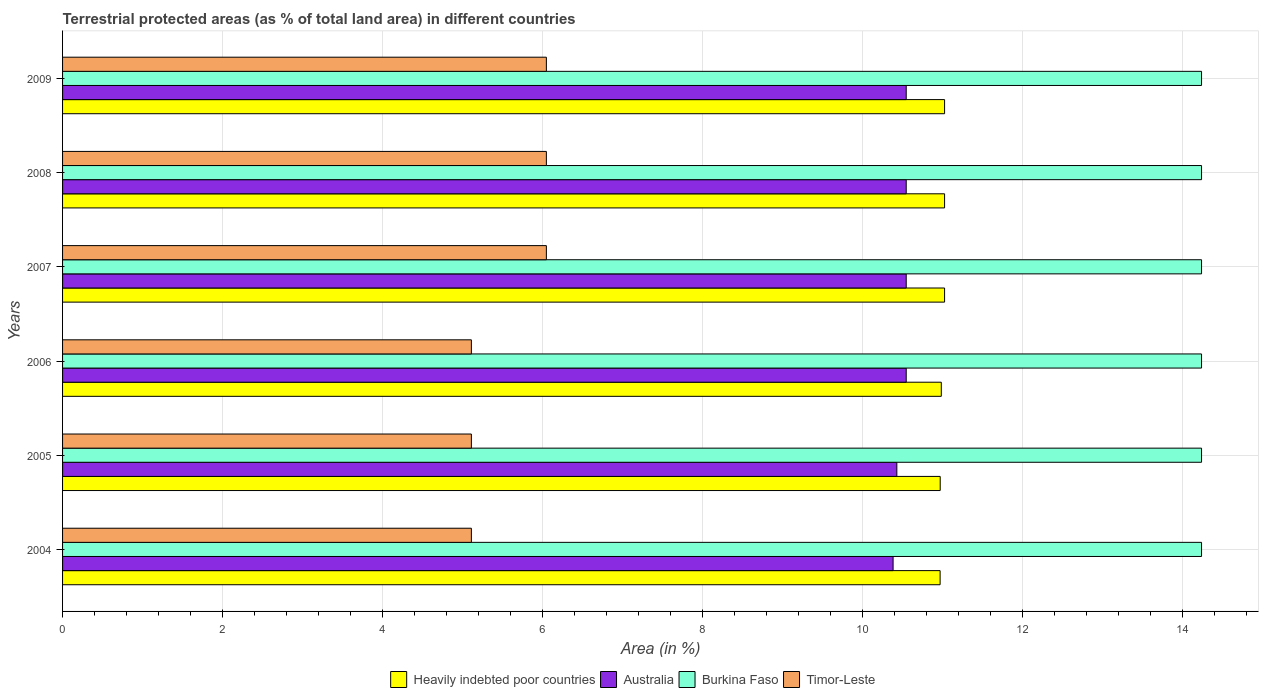How many different coloured bars are there?
Provide a succinct answer. 4. How many bars are there on the 6th tick from the bottom?
Provide a succinct answer. 4. What is the percentage of terrestrial protected land in Timor-Leste in 2006?
Offer a very short reply. 5.11. Across all years, what is the maximum percentage of terrestrial protected land in Heavily indebted poor countries?
Give a very brief answer. 11.03. Across all years, what is the minimum percentage of terrestrial protected land in Australia?
Give a very brief answer. 10.39. In which year was the percentage of terrestrial protected land in Timor-Leste minimum?
Ensure brevity in your answer.  2004. What is the total percentage of terrestrial protected land in Australia in the graph?
Provide a short and direct response. 63.02. What is the difference between the percentage of terrestrial protected land in Australia in 2004 and that in 2007?
Make the answer very short. -0.16. What is the difference between the percentage of terrestrial protected land in Heavily indebted poor countries in 2004 and the percentage of terrestrial protected land in Burkina Faso in 2009?
Your answer should be compact. -3.27. What is the average percentage of terrestrial protected land in Burkina Faso per year?
Provide a succinct answer. 14.24. In the year 2009, what is the difference between the percentage of terrestrial protected land in Heavily indebted poor countries and percentage of terrestrial protected land in Australia?
Offer a terse response. 0.48. In how many years, is the percentage of terrestrial protected land in Timor-Leste greater than 8.8 %?
Your answer should be very brief. 0. What is the ratio of the percentage of terrestrial protected land in Timor-Leste in 2005 to that in 2007?
Offer a very short reply. 0.84. Is the percentage of terrestrial protected land in Heavily indebted poor countries in 2007 less than that in 2009?
Provide a short and direct response. No. Is the difference between the percentage of terrestrial protected land in Heavily indebted poor countries in 2005 and 2008 greater than the difference between the percentage of terrestrial protected land in Australia in 2005 and 2008?
Keep it short and to the point. Yes. What is the difference between the highest and the lowest percentage of terrestrial protected land in Australia?
Your response must be concise. 0.16. Is it the case that in every year, the sum of the percentage of terrestrial protected land in Timor-Leste and percentage of terrestrial protected land in Australia is greater than the sum of percentage of terrestrial protected land in Heavily indebted poor countries and percentage of terrestrial protected land in Burkina Faso?
Offer a very short reply. No. What does the 4th bar from the bottom in 2007 represents?
Keep it short and to the point. Timor-Leste. Is it the case that in every year, the sum of the percentage of terrestrial protected land in Timor-Leste and percentage of terrestrial protected land in Burkina Faso is greater than the percentage of terrestrial protected land in Australia?
Your answer should be compact. Yes. Are all the bars in the graph horizontal?
Provide a succinct answer. Yes. What is the difference between two consecutive major ticks on the X-axis?
Provide a succinct answer. 2. Does the graph contain grids?
Provide a succinct answer. Yes. Where does the legend appear in the graph?
Keep it short and to the point. Bottom center. How many legend labels are there?
Your answer should be very brief. 4. What is the title of the graph?
Give a very brief answer. Terrestrial protected areas (as % of total land area) in different countries. Does "Georgia" appear as one of the legend labels in the graph?
Offer a terse response. No. What is the label or title of the X-axis?
Your answer should be very brief. Area (in %). What is the Area (in %) in Heavily indebted poor countries in 2004?
Your answer should be compact. 10.97. What is the Area (in %) of Australia in 2004?
Provide a short and direct response. 10.39. What is the Area (in %) of Burkina Faso in 2004?
Offer a terse response. 14.24. What is the Area (in %) of Timor-Leste in 2004?
Offer a terse response. 5.11. What is the Area (in %) in Heavily indebted poor countries in 2005?
Provide a succinct answer. 10.98. What is the Area (in %) in Australia in 2005?
Your answer should be very brief. 10.43. What is the Area (in %) in Burkina Faso in 2005?
Your answer should be compact. 14.24. What is the Area (in %) of Timor-Leste in 2005?
Offer a very short reply. 5.11. What is the Area (in %) in Heavily indebted poor countries in 2006?
Offer a very short reply. 10.99. What is the Area (in %) of Australia in 2006?
Ensure brevity in your answer.  10.55. What is the Area (in %) of Burkina Faso in 2006?
Your response must be concise. 14.24. What is the Area (in %) in Timor-Leste in 2006?
Offer a very short reply. 5.11. What is the Area (in %) of Heavily indebted poor countries in 2007?
Keep it short and to the point. 11.03. What is the Area (in %) in Australia in 2007?
Offer a very short reply. 10.55. What is the Area (in %) of Burkina Faso in 2007?
Offer a very short reply. 14.24. What is the Area (in %) of Timor-Leste in 2007?
Your answer should be compact. 6.05. What is the Area (in %) of Heavily indebted poor countries in 2008?
Offer a terse response. 11.03. What is the Area (in %) in Australia in 2008?
Keep it short and to the point. 10.55. What is the Area (in %) in Burkina Faso in 2008?
Provide a short and direct response. 14.24. What is the Area (in %) in Timor-Leste in 2008?
Give a very brief answer. 6.05. What is the Area (in %) in Heavily indebted poor countries in 2009?
Your answer should be compact. 11.03. What is the Area (in %) in Australia in 2009?
Ensure brevity in your answer.  10.55. What is the Area (in %) of Burkina Faso in 2009?
Offer a terse response. 14.24. What is the Area (in %) of Timor-Leste in 2009?
Ensure brevity in your answer.  6.05. Across all years, what is the maximum Area (in %) in Heavily indebted poor countries?
Provide a succinct answer. 11.03. Across all years, what is the maximum Area (in %) in Australia?
Make the answer very short. 10.55. Across all years, what is the maximum Area (in %) of Burkina Faso?
Ensure brevity in your answer.  14.24. Across all years, what is the maximum Area (in %) of Timor-Leste?
Give a very brief answer. 6.05. Across all years, what is the minimum Area (in %) of Heavily indebted poor countries?
Provide a succinct answer. 10.97. Across all years, what is the minimum Area (in %) in Australia?
Your answer should be very brief. 10.39. Across all years, what is the minimum Area (in %) of Burkina Faso?
Your answer should be compact. 14.24. Across all years, what is the minimum Area (in %) of Timor-Leste?
Give a very brief answer. 5.11. What is the total Area (in %) of Heavily indebted poor countries in the graph?
Make the answer very short. 66.03. What is the total Area (in %) of Australia in the graph?
Your answer should be compact. 63.02. What is the total Area (in %) in Burkina Faso in the graph?
Provide a succinct answer. 85.46. What is the total Area (in %) of Timor-Leste in the graph?
Provide a short and direct response. 33.49. What is the difference between the Area (in %) in Heavily indebted poor countries in 2004 and that in 2005?
Offer a very short reply. -0. What is the difference between the Area (in %) in Australia in 2004 and that in 2005?
Make the answer very short. -0.05. What is the difference between the Area (in %) of Timor-Leste in 2004 and that in 2005?
Give a very brief answer. 0. What is the difference between the Area (in %) in Heavily indebted poor countries in 2004 and that in 2006?
Make the answer very short. -0.01. What is the difference between the Area (in %) in Australia in 2004 and that in 2006?
Ensure brevity in your answer.  -0.16. What is the difference between the Area (in %) in Burkina Faso in 2004 and that in 2006?
Your answer should be very brief. 0. What is the difference between the Area (in %) in Timor-Leste in 2004 and that in 2006?
Offer a very short reply. 0. What is the difference between the Area (in %) of Heavily indebted poor countries in 2004 and that in 2007?
Your answer should be compact. -0.06. What is the difference between the Area (in %) of Australia in 2004 and that in 2007?
Provide a succinct answer. -0.16. What is the difference between the Area (in %) of Timor-Leste in 2004 and that in 2007?
Keep it short and to the point. -0.94. What is the difference between the Area (in %) in Heavily indebted poor countries in 2004 and that in 2008?
Make the answer very short. -0.06. What is the difference between the Area (in %) in Australia in 2004 and that in 2008?
Your response must be concise. -0.16. What is the difference between the Area (in %) of Burkina Faso in 2004 and that in 2008?
Offer a terse response. 0. What is the difference between the Area (in %) of Timor-Leste in 2004 and that in 2008?
Offer a terse response. -0.94. What is the difference between the Area (in %) of Heavily indebted poor countries in 2004 and that in 2009?
Provide a succinct answer. -0.06. What is the difference between the Area (in %) in Australia in 2004 and that in 2009?
Give a very brief answer. -0.16. What is the difference between the Area (in %) in Timor-Leste in 2004 and that in 2009?
Keep it short and to the point. -0.94. What is the difference between the Area (in %) in Heavily indebted poor countries in 2005 and that in 2006?
Your answer should be very brief. -0.01. What is the difference between the Area (in %) in Australia in 2005 and that in 2006?
Keep it short and to the point. -0.12. What is the difference between the Area (in %) in Heavily indebted poor countries in 2005 and that in 2007?
Your response must be concise. -0.05. What is the difference between the Area (in %) of Australia in 2005 and that in 2007?
Ensure brevity in your answer.  -0.12. What is the difference between the Area (in %) of Timor-Leste in 2005 and that in 2007?
Offer a terse response. -0.94. What is the difference between the Area (in %) of Heavily indebted poor countries in 2005 and that in 2008?
Offer a terse response. -0.05. What is the difference between the Area (in %) of Australia in 2005 and that in 2008?
Ensure brevity in your answer.  -0.12. What is the difference between the Area (in %) of Timor-Leste in 2005 and that in 2008?
Give a very brief answer. -0.94. What is the difference between the Area (in %) in Heavily indebted poor countries in 2005 and that in 2009?
Your response must be concise. -0.05. What is the difference between the Area (in %) of Australia in 2005 and that in 2009?
Offer a very short reply. -0.12. What is the difference between the Area (in %) of Burkina Faso in 2005 and that in 2009?
Offer a terse response. 0. What is the difference between the Area (in %) in Timor-Leste in 2005 and that in 2009?
Provide a succinct answer. -0.94. What is the difference between the Area (in %) in Heavily indebted poor countries in 2006 and that in 2007?
Provide a succinct answer. -0.04. What is the difference between the Area (in %) in Timor-Leste in 2006 and that in 2007?
Keep it short and to the point. -0.94. What is the difference between the Area (in %) in Heavily indebted poor countries in 2006 and that in 2008?
Offer a very short reply. -0.04. What is the difference between the Area (in %) in Australia in 2006 and that in 2008?
Your response must be concise. -0. What is the difference between the Area (in %) in Timor-Leste in 2006 and that in 2008?
Make the answer very short. -0.94. What is the difference between the Area (in %) of Heavily indebted poor countries in 2006 and that in 2009?
Provide a short and direct response. -0.04. What is the difference between the Area (in %) in Australia in 2006 and that in 2009?
Offer a very short reply. -0. What is the difference between the Area (in %) in Timor-Leste in 2006 and that in 2009?
Offer a terse response. -0.94. What is the difference between the Area (in %) of Heavily indebted poor countries in 2007 and that in 2008?
Provide a succinct answer. 0. What is the difference between the Area (in %) of Australia in 2007 and that in 2008?
Your response must be concise. 0. What is the difference between the Area (in %) of Burkina Faso in 2007 and that in 2008?
Make the answer very short. 0. What is the difference between the Area (in %) in Timor-Leste in 2007 and that in 2009?
Give a very brief answer. 0. What is the difference between the Area (in %) in Heavily indebted poor countries in 2008 and that in 2009?
Give a very brief answer. 0. What is the difference between the Area (in %) of Australia in 2008 and that in 2009?
Your answer should be compact. 0. What is the difference between the Area (in %) of Burkina Faso in 2008 and that in 2009?
Your response must be concise. 0. What is the difference between the Area (in %) in Timor-Leste in 2008 and that in 2009?
Provide a short and direct response. 0. What is the difference between the Area (in %) in Heavily indebted poor countries in 2004 and the Area (in %) in Australia in 2005?
Offer a terse response. 0.54. What is the difference between the Area (in %) in Heavily indebted poor countries in 2004 and the Area (in %) in Burkina Faso in 2005?
Keep it short and to the point. -3.27. What is the difference between the Area (in %) in Heavily indebted poor countries in 2004 and the Area (in %) in Timor-Leste in 2005?
Make the answer very short. 5.86. What is the difference between the Area (in %) of Australia in 2004 and the Area (in %) of Burkina Faso in 2005?
Your response must be concise. -3.86. What is the difference between the Area (in %) in Australia in 2004 and the Area (in %) in Timor-Leste in 2005?
Provide a succinct answer. 5.27. What is the difference between the Area (in %) of Burkina Faso in 2004 and the Area (in %) of Timor-Leste in 2005?
Offer a very short reply. 9.13. What is the difference between the Area (in %) of Heavily indebted poor countries in 2004 and the Area (in %) of Australia in 2006?
Offer a very short reply. 0.42. What is the difference between the Area (in %) in Heavily indebted poor countries in 2004 and the Area (in %) in Burkina Faso in 2006?
Your response must be concise. -3.27. What is the difference between the Area (in %) in Heavily indebted poor countries in 2004 and the Area (in %) in Timor-Leste in 2006?
Offer a terse response. 5.86. What is the difference between the Area (in %) in Australia in 2004 and the Area (in %) in Burkina Faso in 2006?
Offer a very short reply. -3.86. What is the difference between the Area (in %) in Australia in 2004 and the Area (in %) in Timor-Leste in 2006?
Your response must be concise. 5.27. What is the difference between the Area (in %) in Burkina Faso in 2004 and the Area (in %) in Timor-Leste in 2006?
Make the answer very short. 9.13. What is the difference between the Area (in %) in Heavily indebted poor countries in 2004 and the Area (in %) in Australia in 2007?
Provide a short and direct response. 0.42. What is the difference between the Area (in %) of Heavily indebted poor countries in 2004 and the Area (in %) of Burkina Faso in 2007?
Give a very brief answer. -3.27. What is the difference between the Area (in %) of Heavily indebted poor countries in 2004 and the Area (in %) of Timor-Leste in 2007?
Offer a very short reply. 4.92. What is the difference between the Area (in %) of Australia in 2004 and the Area (in %) of Burkina Faso in 2007?
Make the answer very short. -3.86. What is the difference between the Area (in %) in Australia in 2004 and the Area (in %) in Timor-Leste in 2007?
Give a very brief answer. 4.34. What is the difference between the Area (in %) in Burkina Faso in 2004 and the Area (in %) in Timor-Leste in 2007?
Your answer should be compact. 8.19. What is the difference between the Area (in %) in Heavily indebted poor countries in 2004 and the Area (in %) in Australia in 2008?
Provide a short and direct response. 0.42. What is the difference between the Area (in %) of Heavily indebted poor countries in 2004 and the Area (in %) of Burkina Faso in 2008?
Give a very brief answer. -3.27. What is the difference between the Area (in %) of Heavily indebted poor countries in 2004 and the Area (in %) of Timor-Leste in 2008?
Your answer should be very brief. 4.92. What is the difference between the Area (in %) in Australia in 2004 and the Area (in %) in Burkina Faso in 2008?
Offer a terse response. -3.86. What is the difference between the Area (in %) in Australia in 2004 and the Area (in %) in Timor-Leste in 2008?
Give a very brief answer. 4.34. What is the difference between the Area (in %) of Burkina Faso in 2004 and the Area (in %) of Timor-Leste in 2008?
Provide a short and direct response. 8.19. What is the difference between the Area (in %) of Heavily indebted poor countries in 2004 and the Area (in %) of Australia in 2009?
Provide a short and direct response. 0.42. What is the difference between the Area (in %) of Heavily indebted poor countries in 2004 and the Area (in %) of Burkina Faso in 2009?
Offer a very short reply. -3.27. What is the difference between the Area (in %) of Heavily indebted poor countries in 2004 and the Area (in %) of Timor-Leste in 2009?
Offer a very short reply. 4.92. What is the difference between the Area (in %) in Australia in 2004 and the Area (in %) in Burkina Faso in 2009?
Offer a terse response. -3.86. What is the difference between the Area (in %) of Australia in 2004 and the Area (in %) of Timor-Leste in 2009?
Offer a very short reply. 4.34. What is the difference between the Area (in %) of Burkina Faso in 2004 and the Area (in %) of Timor-Leste in 2009?
Give a very brief answer. 8.19. What is the difference between the Area (in %) in Heavily indebted poor countries in 2005 and the Area (in %) in Australia in 2006?
Give a very brief answer. 0.43. What is the difference between the Area (in %) of Heavily indebted poor countries in 2005 and the Area (in %) of Burkina Faso in 2006?
Provide a short and direct response. -3.27. What is the difference between the Area (in %) of Heavily indebted poor countries in 2005 and the Area (in %) of Timor-Leste in 2006?
Your response must be concise. 5.86. What is the difference between the Area (in %) in Australia in 2005 and the Area (in %) in Burkina Faso in 2006?
Offer a terse response. -3.81. What is the difference between the Area (in %) in Australia in 2005 and the Area (in %) in Timor-Leste in 2006?
Your response must be concise. 5.32. What is the difference between the Area (in %) in Burkina Faso in 2005 and the Area (in %) in Timor-Leste in 2006?
Your response must be concise. 9.13. What is the difference between the Area (in %) in Heavily indebted poor countries in 2005 and the Area (in %) in Australia in 2007?
Offer a very short reply. 0.43. What is the difference between the Area (in %) in Heavily indebted poor countries in 2005 and the Area (in %) in Burkina Faso in 2007?
Your answer should be very brief. -3.27. What is the difference between the Area (in %) in Heavily indebted poor countries in 2005 and the Area (in %) in Timor-Leste in 2007?
Offer a very short reply. 4.92. What is the difference between the Area (in %) in Australia in 2005 and the Area (in %) in Burkina Faso in 2007?
Give a very brief answer. -3.81. What is the difference between the Area (in %) of Australia in 2005 and the Area (in %) of Timor-Leste in 2007?
Your answer should be very brief. 4.38. What is the difference between the Area (in %) of Burkina Faso in 2005 and the Area (in %) of Timor-Leste in 2007?
Give a very brief answer. 8.19. What is the difference between the Area (in %) in Heavily indebted poor countries in 2005 and the Area (in %) in Australia in 2008?
Offer a terse response. 0.43. What is the difference between the Area (in %) of Heavily indebted poor countries in 2005 and the Area (in %) of Burkina Faso in 2008?
Provide a succinct answer. -3.27. What is the difference between the Area (in %) of Heavily indebted poor countries in 2005 and the Area (in %) of Timor-Leste in 2008?
Make the answer very short. 4.92. What is the difference between the Area (in %) in Australia in 2005 and the Area (in %) in Burkina Faso in 2008?
Offer a very short reply. -3.81. What is the difference between the Area (in %) in Australia in 2005 and the Area (in %) in Timor-Leste in 2008?
Make the answer very short. 4.38. What is the difference between the Area (in %) of Burkina Faso in 2005 and the Area (in %) of Timor-Leste in 2008?
Make the answer very short. 8.19. What is the difference between the Area (in %) of Heavily indebted poor countries in 2005 and the Area (in %) of Australia in 2009?
Ensure brevity in your answer.  0.43. What is the difference between the Area (in %) in Heavily indebted poor countries in 2005 and the Area (in %) in Burkina Faso in 2009?
Offer a terse response. -3.27. What is the difference between the Area (in %) of Heavily indebted poor countries in 2005 and the Area (in %) of Timor-Leste in 2009?
Offer a very short reply. 4.92. What is the difference between the Area (in %) of Australia in 2005 and the Area (in %) of Burkina Faso in 2009?
Provide a short and direct response. -3.81. What is the difference between the Area (in %) in Australia in 2005 and the Area (in %) in Timor-Leste in 2009?
Provide a short and direct response. 4.38. What is the difference between the Area (in %) in Burkina Faso in 2005 and the Area (in %) in Timor-Leste in 2009?
Your answer should be compact. 8.19. What is the difference between the Area (in %) in Heavily indebted poor countries in 2006 and the Area (in %) in Australia in 2007?
Ensure brevity in your answer.  0.44. What is the difference between the Area (in %) of Heavily indebted poor countries in 2006 and the Area (in %) of Burkina Faso in 2007?
Make the answer very short. -3.25. What is the difference between the Area (in %) of Heavily indebted poor countries in 2006 and the Area (in %) of Timor-Leste in 2007?
Provide a short and direct response. 4.94. What is the difference between the Area (in %) in Australia in 2006 and the Area (in %) in Burkina Faso in 2007?
Provide a short and direct response. -3.69. What is the difference between the Area (in %) in Australia in 2006 and the Area (in %) in Timor-Leste in 2007?
Provide a short and direct response. 4.5. What is the difference between the Area (in %) of Burkina Faso in 2006 and the Area (in %) of Timor-Leste in 2007?
Ensure brevity in your answer.  8.19. What is the difference between the Area (in %) of Heavily indebted poor countries in 2006 and the Area (in %) of Australia in 2008?
Offer a terse response. 0.44. What is the difference between the Area (in %) in Heavily indebted poor countries in 2006 and the Area (in %) in Burkina Faso in 2008?
Keep it short and to the point. -3.25. What is the difference between the Area (in %) of Heavily indebted poor countries in 2006 and the Area (in %) of Timor-Leste in 2008?
Provide a succinct answer. 4.94. What is the difference between the Area (in %) of Australia in 2006 and the Area (in %) of Burkina Faso in 2008?
Your answer should be very brief. -3.69. What is the difference between the Area (in %) of Australia in 2006 and the Area (in %) of Timor-Leste in 2008?
Provide a short and direct response. 4.5. What is the difference between the Area (in %) of Burkina Faso in 2006 and the Area (in %) of Timor-Leste in 2008?
Ensure brevity in your answer.  8.19. What is the difference between the Area (in %) of Heavily indebted poor countries in 2006 and the Area (in %) of Australia in 2009?
Your answer should be very brief. 0.44. What is the difference between the Area (in %) of Heavily indebted poor countries in 2006 and the Area (in %) of Burkina Faso in 2009?
Offer a very short reply. -3.25. What is the difference between the Area (in %) in Heavily indebted poor countries in 2006 and the Area (in %) in Timor-Leste in 2009?
Your answer should be compact. 4.94. What is the difference between the Area (in %) in Australia in 2006 and the Area (in %) in Burkina Faso in 2009?
Provide a succinct answer. -3.69. What is the difference between the Area (in %) in Australia in 2006 and the Area (in %) in Timor-Leste in 2009?
Provide a short and direct response. 4.5. What is the difference between the Area (in %) of Burkina Faso in 2006 and the Area (in %) of Timor-Leste in 2009?
Ensure brevity in your answer.  8.19. What is the difference between the Area (in %) in Heavily indebted poor countries in 2007 and the Area (in %) in Australia in 2008?
Provide a succinct answer. 0.48. What is the difference between the Area (in %) of Heavily indebted poor countries in 2007 and the Area (in %) of Burkina Faso in 2008?
Make the answer very short. -3.21. What is the difference between the Area (in %) of Heavily indebted poor countries in 2007 and the Area (in %) of Timor-Leste in 2008?
Offer a terse response. 4.98. What is the difference between the Area (in %) of Australia in 2007 and the Area (in %) of Burkina Faso in 2008?
Your answer should be compact. -3.69. What is the difference between the Area (in %) of Australia in 2007 and the Area (in %) of Timor-Leste in 2008?
Offer a terse response. 4.5. What is the difference between the Area (in %) of Burkina Faso in 2007 and the Area (in %) of Timor-Leste in 2008?
Offer a terse response. 8.19. What is the difference between the Area (in %) in Heavily indebted poor countries in 2007 and the Area (in %) in Australia in 2009?
Give a very brief answer. 0.48. What is the difference between the Area (in %) of Heavily indebted poor countries in 2007 and the Area (in %) of Burkina Faso in 2009?
Make the answer very short. -3.21. What is the difference between the Area (in %) of Heavily indebted poor countries in 2007 and the Area (in %) of Timor-Leste in 2009?
Your response must be concise. 4.98. What is the difference between the Area (in %) in Australia in 2007 and the Area (in %) in Burkina Faso in 2009?
Provide a succinct answer. -3.69. What is the difference between the Area (in %) of Australia in 2007 and the Area (in %) of Timor-Leste in 2009?
Your response must be concise. 4.5. What is the difference between the Area (in %) of Burkina Faso in 2007 and the Area (in %) of Timor-Leste in 2009?
Provide a short and direct response. 8.19. What is the difference between the Area (in %) in Heavily indebted poor countries in 2008 and the Area (in %) in Australia in 2009?
Your answer should be very brief. 0.48. What is the difference between the Area (in %) of Heavily indebted poor countries in 2008 and the Area (in %) of Burkina Faso in 2009?
Provide a short and direct response. -3.21. What is the difference between the Area (in %) of Heavily indebted poor countries in 2008 and the Area (in %) of Timor-Leste in 2009?
Your answer should be compact. 4.98. What is the difference between the Area (in %) of Australia in 2008 and the Area (in %) of Burkina Faso in 2009?
Keep it short and to the point. -3.69. What is the difference between the Area (in %) of Australia in 2008 and the Area (in %) of Timor-Leste in 2009?
Ensure brevity in your answer.  4.5. What is the difference between the Area (in %) in Burkina Faso in 2008 and the Area (in %) in Timor-Leste in 2009?
Give a very brief answer. 8.19. What is the average Area (in %) in Heavily indebted poor countries per year?
Give a very brief answer. 11. What is the average Area (in %) in Australia per year?
Make the answer very short. 10.5. What is the average Area (in %) of Burkina Faso per year?
Your answer should be compact. 14.24. What is the average Area (in %) in Timor-Leste per year?
Provide a short and direct response. 5.58. In the year 2004, what is the difference between the Area (in %) of Heavily indebted poor countries and Area (in %) of Australia?
Offer a very short reply. 0.59. In the year 2004, what is the difference between the Area (in %) of Heavily indebted poor countries and Area (in %) of Burkina Faso?
Provide a succinct answer. -3.27. In the year 2004, what is the difference between the Area (in %) of Heavily indebted poor countries and Area (in %) of Timor-Leste?
Make the answer very short. 5.86. In the year 2004, what is the difference between the Area (in %) in Australia and Area (in %) in Burkina Faso?
Offer a very short reply. -3.86. In the year 2004, what is the difference between the Area (in %) of Australia and Area (in %) of Timor-Leste?
Your response must be concise. 5.27. In the year 2004, what is the difference between the Area (in %) in Burkina Faso and Area (in %) in Timor-Leste?
Make the answer very short. 9.13. In the year 2005, what is the difference between the Area (in %) in Heavily indebted poor countries and Area (in %) in Australia?
Ensure brevity in your answer.  0.54. In the year 2005, what is the difference between the Area (in %) in Heavily indebted poor countries and Area (in %) in Burkina Faso?
Provide a succinct answer. -3.27. In the year 2005, what is the difference between the Area (in %) in Heavily indebted poor countries and Area (in %) in Timor-Leste?
Keep it short and to the point. 5.86. In the year 2005, what is the difference between the Area (in %) in Australia and Area (in %) in Burkina Faso?
Your answer should be compact. -3.81. In the year 2005, what is the difference between the Area (in %) in Australia and Area (in %) in Timor-Leste?
Provide a succinct answer. 5.32. In the year 2005, what is the difference between the Area (in %) in Burkina Faso and Area (in %) in Timor-Leste?
Offer a very short reply. 9.13. In the year 2006, what is the difference between the Area (in %) in Heavily indebted poor countries and Area (in %) in Australia?
Keep it short and to the point. 0.44. In the year 2006, what is the difference between the Area (in %) of Heavily indebted poor countries and Area (in %) of Burkina Faso?
Ensure brevity in your answer.  -3.25. In the year 2006, what is the difference between the Area (in %) of Heavily indebted poor countries and Area (in %) of Timor-Leste?
Offer a very short reply. 5.88. In the year 2006, what is the difference between the Area (in %) of Australia and Area (in %) of Burkina Faso?
Your answer should be compact. -3.69. In the year 2006, what is the difference between the Area (in %) of Australia and Area (in %) of Timor-Leste?
Provide a succinct answer. 5.44. In the year 2006, what is the difference between the Area (in %) of Burkina Faso and Area (in %) of Timor-Leste?
Keep it short and to the point. 9.13. In the year 2007, what is the difference between the Area (in %) in Heavily indebted poor countries and Area (in %) in Australia?
Your answer should be compact. 0.48. In the year 2007, what is the difference between the Area (in %) in Heavily indebted poor countries and Area (in %) in Burkina Faso?
Your answer should be compact. -3.21. In the year 2007, what is the difference between the Area (in %) in Heavily indebted poor countries and Area (in %) in Timor-Leste?
Offer a terse response. 4.98. In the year 2007, what is the difference between the Area (in %) in Australia and Area (in %) in Burkina Faso?
Keep it short and to the point. -3.69. In the year 2007, what is the difference between the Area (in %) in Australia and Area (in %) in Timor-Leste?
Offer a terse response. 4.5. In the year 2007, what is the difference between the Area (in %) in Burkina Faso and Area (in %) in Timor-Leste?
Your answer should be very brief. 8.19. In the year 2008, what is the difference between the Area (in %) of Heavily indebted poor countries and Area (in %) of Australia?
Your response must be concise. 0.48. In the year 2008, what is the difference between the Area (in %) in Heavily indebted poor countries and Area (in %) in Burkina Faso?
Offer a very short reply. -3.21. In the year 2008, what is the difference between the Area (in %) in Heavily indebted poor countries and Area (in %) in Timor-Leste?
Keep it short and to the point. 4.98. In the year 2008, what is the difference between the Area (in %) in Australia and Area (in %) in Burkina Faso?
Make the answer very short. -3.69. In the year 2008, what is the difference between the Area (in %) of Australia and Area (in %) of Timor-Leste?
Offer a very short reply. 4.5. In the year 2008, what is the difference between the Area (in %) of Burkina Faso and Area (in %) of Timor-Leste?
Provide a short and direct response. 8.19. In the year 2009, what is the difference between the Area (in %) in Heavily indebted poor countries and Area (in %) in Australia?
Provide a short and direct response. 0.48. In the year 2009, what is the difference between the Area (in %) in Heavily indebted poor countries and Area (in %) in Burkina Faso?
Offer a terse response. -3.21. In the year 2009, what is the difference between the Area (in %) in Heavily indebted poor countries and Area (in %) in Timor-Leste?
Ensure brevity in your answer.  4.98. In the year 2009, what is the difference between the Area (in %) in Australia and Area (in %) in Burkina Faso?
Provide a short and direct response. -3.69. In the year 2009, what is the difference between the Area (in %) in Australia and Area (in %) in Timor-Leste?
Ensure brevity in your answer.  4.5. In the year 2009, what is the difference between the Area (in %) of Burkina Faso and Area (in %) of Timor-Leste?
Give a very brief answer. 8.19. What is the ratio of the Area (in %) of Heavily indebted poor countries in 2004 to that in 2005?
Your answer should be compact. 1. What is the ratio of the Area (in %) of Australia in 2004 to that in 2005?
Keep it short and to the point. 1. What is the ratio of the Area (in %) of Timor-Leste in 2004 to that in 2005?
Ensure brevity in your answer.  1. What is the ratio of the Area (in %) in Australia in 2004 to that in 2006?
Your answer should be compact. 0.98. What is the ratio of the Area (in %) in Burkina Faso in 2004 to that in 2006?
Provide a succinct answer. 1. What is the ratio of the Area (in %) in Australia in 2004 to that in 2007?
Ensure brevity in your answer.  0.98. What is the ratio of the Area (in %) in Burkina Faso in 2004 to that in 2007?
Give a very brief answer. 1. What is the ratio of the Area (in %) of Timor-Leste in 2004 to that in 2007?
Your response must be concise. 0.84. What is the ratio of the Area (in %) of Heavily indebted poor countries in 2004 to that in 2008?
Offer a very short reply. 0.99. What is the ratio of the Area (in %) in Australia in 2004 to that in 2008?
Offer a terse response. 0.98. What is the ratio of the Area (in %) in Timor-Leste in 2004 to that in 2008?
Offer a terse response. 0.84. What is the ratio of the Area (in %) of Australia in 2004 to that in 2009?
Your answer should be compact. 0.98. What is the ratio of the Area (in %) of Timor-Leste in 2004 to that in 2009?
Make the answer very short. 0.84. What is the ratio of the Area (in %) of Australia in 2005 to that in 2006?
Give a very brief answer. 0.99. What is the ratio of the Area (in %) of Timor-Leste in 2005 to that in 2006?
Offer a terse response. 1. What is the ratio of the Area (in %) of Australia in 2005 to that in 2007?
Provide a short and direct response. 0.99. What is the ratio of the Area (in %) of Timor-Leste in 2005 to that in 2007?
Your answer should be very brief. 0.84. What is the ratio of the Area (in %) of Australia in 2005 to that in 2008?
Ensure brevity in your answer.  0.99. What is the ratio of the Area (in %) of Burkina Faso in 2005 to that in 2008?
Provide a short and direct response. 1. What is the ratio of the Area (in %) in Timor-Leste in 2005 to that in 2008?
Your answer should be compact. 0.84. What is the ratio of the Area (in %) in Heavily indebted poor countries in 2005 to that in 2009?
Your response must be concise. 0.99. What is the ratio of the Area (in %) in Australia in 2005 to that in 2009?
Your answer should be very brief. 0.99. What is the ratio of the Area (in %) in Burkina Faso in 2005 to that in 2009?
Ensure brevity in your answer.  1. What is the ratio of the Area (in %) of Timor-Leste in 2005 to that in 2009?
Provide a succinct answer. 0.84. What is the ratio of the Area (in %) in Heavily indebted poor countries in 2006 to that in 2007?
Your answer should be very brief. 1. What is the ratio of the Area (in %) of Australia in 2006 to that in 2007?
Keep it short and to the point. 1. What is the ratio of the Area (in %) in Burkina Faso in 2006 to that in 2007?
Your answer should be compact. 1. What is the ratio of the Area (in %) in Timor-Leste in 2006 to that in 2007?
Keep it short and to the point. 0.84. What is the ratio of the Area (in %) in Heavily indebted poor countries in 2006 to that in 2008?
Your response must be concise. 1. What is the ratio of the Area (in %) of Australia in 2006 to that in 2008?
Provide a succinct answer. 1. What is the ratio of the Area (in %) of Burkina Faso in 2006 to that in 2008?
Your answer should be very brief. 1. What is the ratio of the Area (in %) of Timor-Leste in 2006 to that in 2008?
Your answer should be compact. 0.84. What is the ratio of the Area (in %) in Heavily indebted poor countries in 2006 to that in 2009?
Your answer should be compact. 1. What is the ratio of the Area (in %) of Australia in 2006 to that in 2009?
Provide a succinct answer. 1. What is the ratio of the Area (in %) in Timor-Leste in 2006 to that in 2009?
Offer a very short reply. 0.84. What is the ratio of the Area (in %) in Heavily indebted poor countries in 2007 to that in 2008?
Your answer should be compact. 1. What is the ratio of the Area (in %) of Burkina Faso in 2007 to that in 2008?
Make the answer very short. 1. What is the ratio of the Area (in %) of Timor-Leste in 2007 to that in 2008?
Give a very brief answer. 1. What is the ratio of the Area (in %) of Heavily indebted poor countries in 2007 to that in 2009?
Your answer should be compact. 1. What is the ratio of the Area (in %) in Australia in 2007 to that in 2009?
Your response must be concise. 1. What is the ratio of the Area (in %) of Australia in 2008 to that in 2009?
Keep it short and to the point. 1. What is the ratio of the Area (in %) of Timor-Leste in 2008 to that in 2009?
Keep it short and to the point. 1. What is the difference between the highest and the second highest Area (in %) of Australia?
Your answer should be very brief. 0. What is the difference between the highest and the second highest Area (in %) in Timor-Leste?
Your response must be concise. 0. What is the difference between the highest and the lowest Area (in %) of Heavily indebted poor countries?
Provide a succinct answer. 0.06. What is the difference between the highest and the lowest Area (in %) of Australia?
Ensure brevity in your answer.  0.16. What is the difference between the highest and the lowest Area (in %) of Burkina Faso?
Offer a very short reply. 0. What is the difference between the highest and the lowest Area (in %) in Timor-Leste?
Make the answer very short. 0.94. 